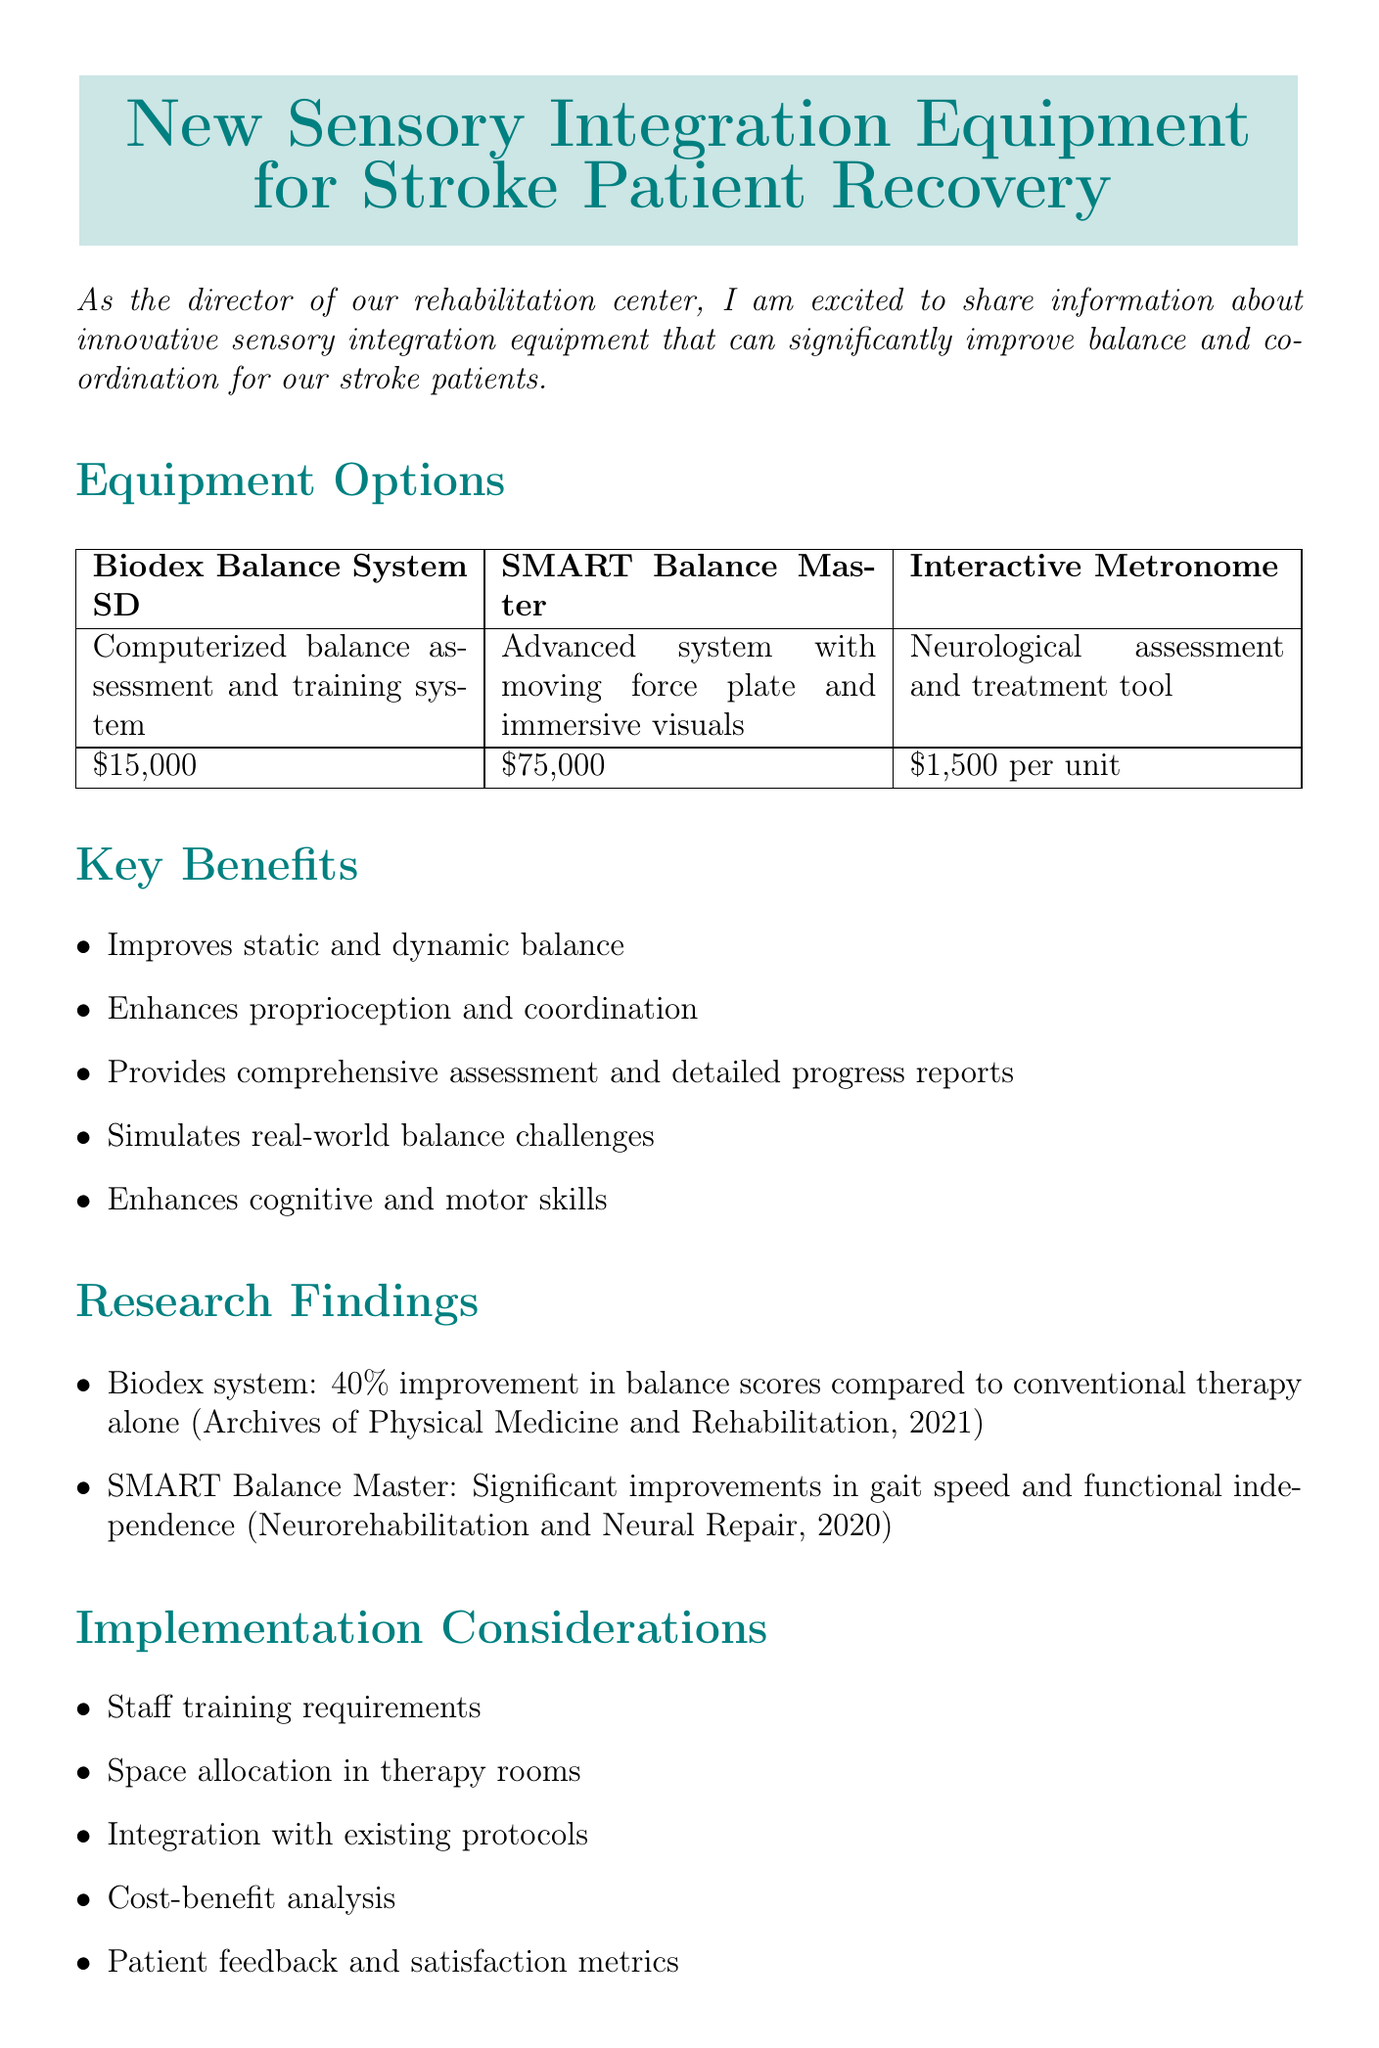What is the title of the memo? The title of the memo is provided at the beginning and addresses new equipment options for stroke patient recovery.
Answer: New Sensory Integration Equipment for Stroke Patient Recovery What is the cost of the Biodex Balance System SD? The document states the cost of this specific equipment option as described in the equipment section.
Answer: $15,000 What improvement percentage did patients using the Biodex system show? The research finding mentions the specific percentage improvement in balance scores achieved by patients utilizing the Biodex system.
Answer: 40% What year was the study on SMART Balance Master published? The document provides the publication year of the research study related to the SMART Balance Master.
Answer: 2020 What are the next steps mentioned in the memo? The memo outlines a sequence of subsequent actions needed to proceed with the recommendations, with a focus on implementation.
Answer: Schedule demonstrations of recommended equipment What is one benefit of the Interactive Metronome? The document lists multiple benefits of this equipment, allowing for retrieval of relevant information.
Answer: Enhances cognitive and motor skills What type of assessment does the SMART Balance Master perform? The description of the SMART Balance Master equipment in the memo indicates its functionality in assessment.
Answer: Comprehensive assessment of sensory organization What is recommended for acquisition based on the memo? The recommendation section specifies which equipment should be prioritized for purchase based on research and budget constraints.
Answer: Biodex Balance System SD and two Interactive Metronome units 